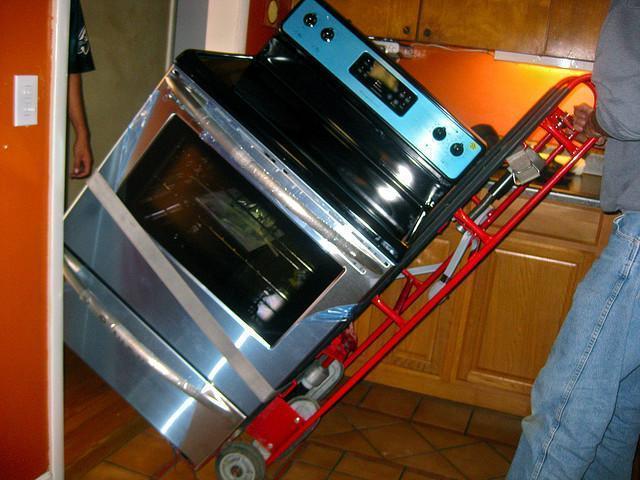How many people can be seen?
Give a very brief answer. 2. How many trains are there?
Give a very brief answer. 0. 